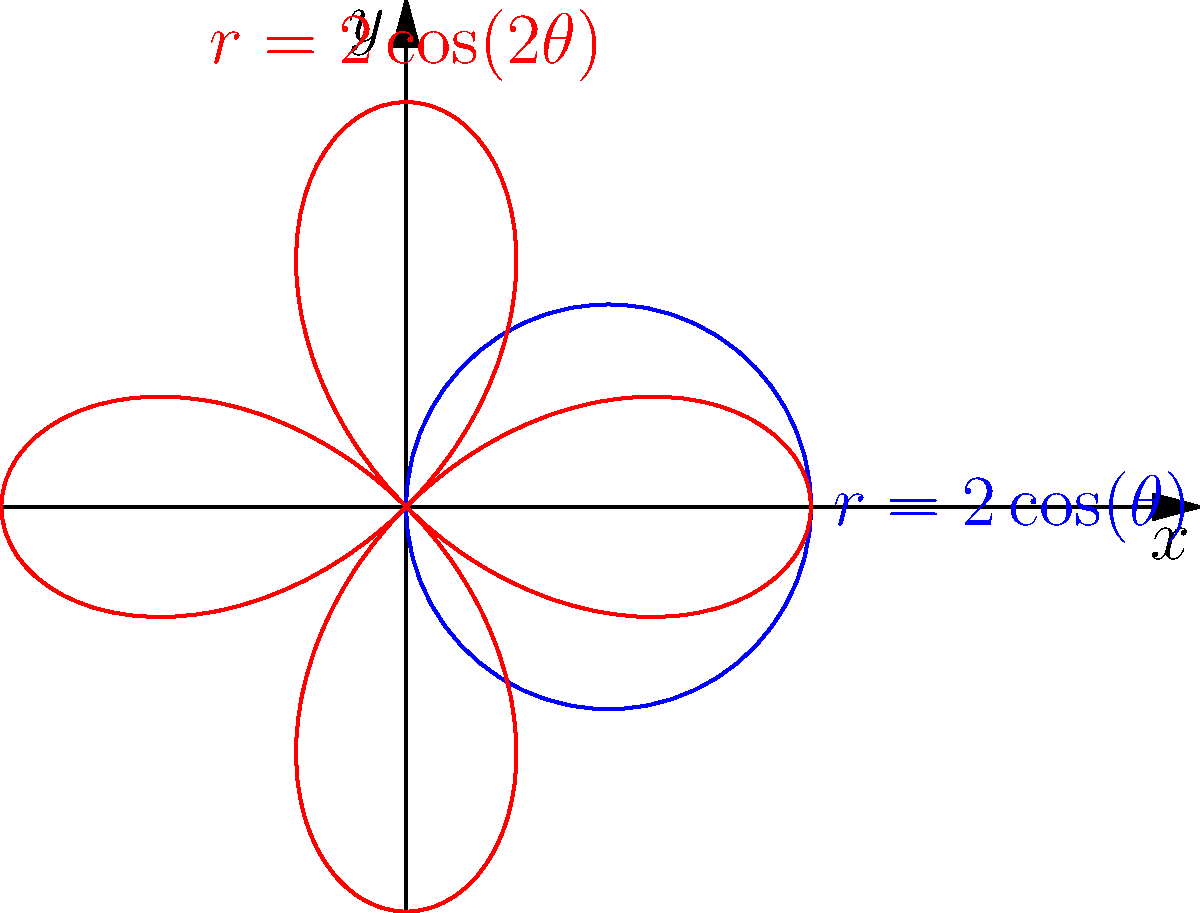Consider the polar curve $r = 2\cos(\theta)$ (shown in blue). What happens to the shape of this curve when the angle is doubled, resulting in $r = 2\cos(2\theta)$ (shown in red)? Describe the main difference in the number of loops. Let's analyze this step-by-step:

1) The original curve $r = 2\cos(\theta)$ (blue) is a circle. This is because:
   - When $\theta = 0$ or $\pi$, $r = \pm 2$, touching the x-axis.
   - When $\theta = \pi/2$ or $3\pi/2$, $r = 0$, passing through the origin.

2) When we double the angle to get $r = 2\cos(2\theta)$ (red), we're essentially making $\theta$ go twice as fast through its cycle.

3) In the original curve, $\cos(\theta)$ completes one full cycle as $\theta$ goes from 0 to $2\pi$.

4) In the new curve, $\cos(2\theta)$ completes two full cycles as $\theta$ goes from 0 to $2\pi$.

5) This means that the new curve will trace out its path twice for one complete revolution of $\theta$.

6) As a result, the new curve forms two loops instead of one.

7) Each loop is smaller than the original circle because the curve now has to fit two loops in the same $2\pi$ range of $\theta$.

Therefore, the main difference is that doubling the angle in the cosine function causes the curve to have two loops instead of one.
Answer: The curve changes from having one loop to having two loops. 